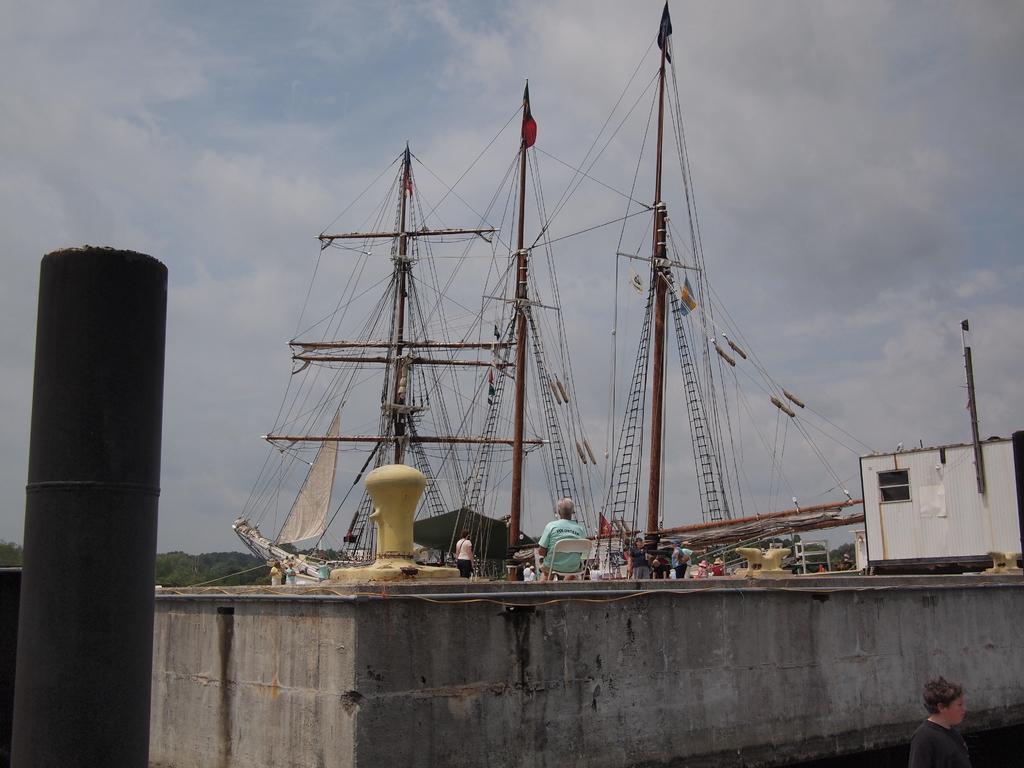In one or two sentences, can you explain what this image depicts? In this image there is one person sitting on a white color chair in the middle and and there are some other persons standing beside to him. There are three ships in the background. There are some trees on the left side to this ships, and there is a black color pipe on the left side of this image. There is a sky at the top of this image. There is one person at the bottom right corner of this image. 